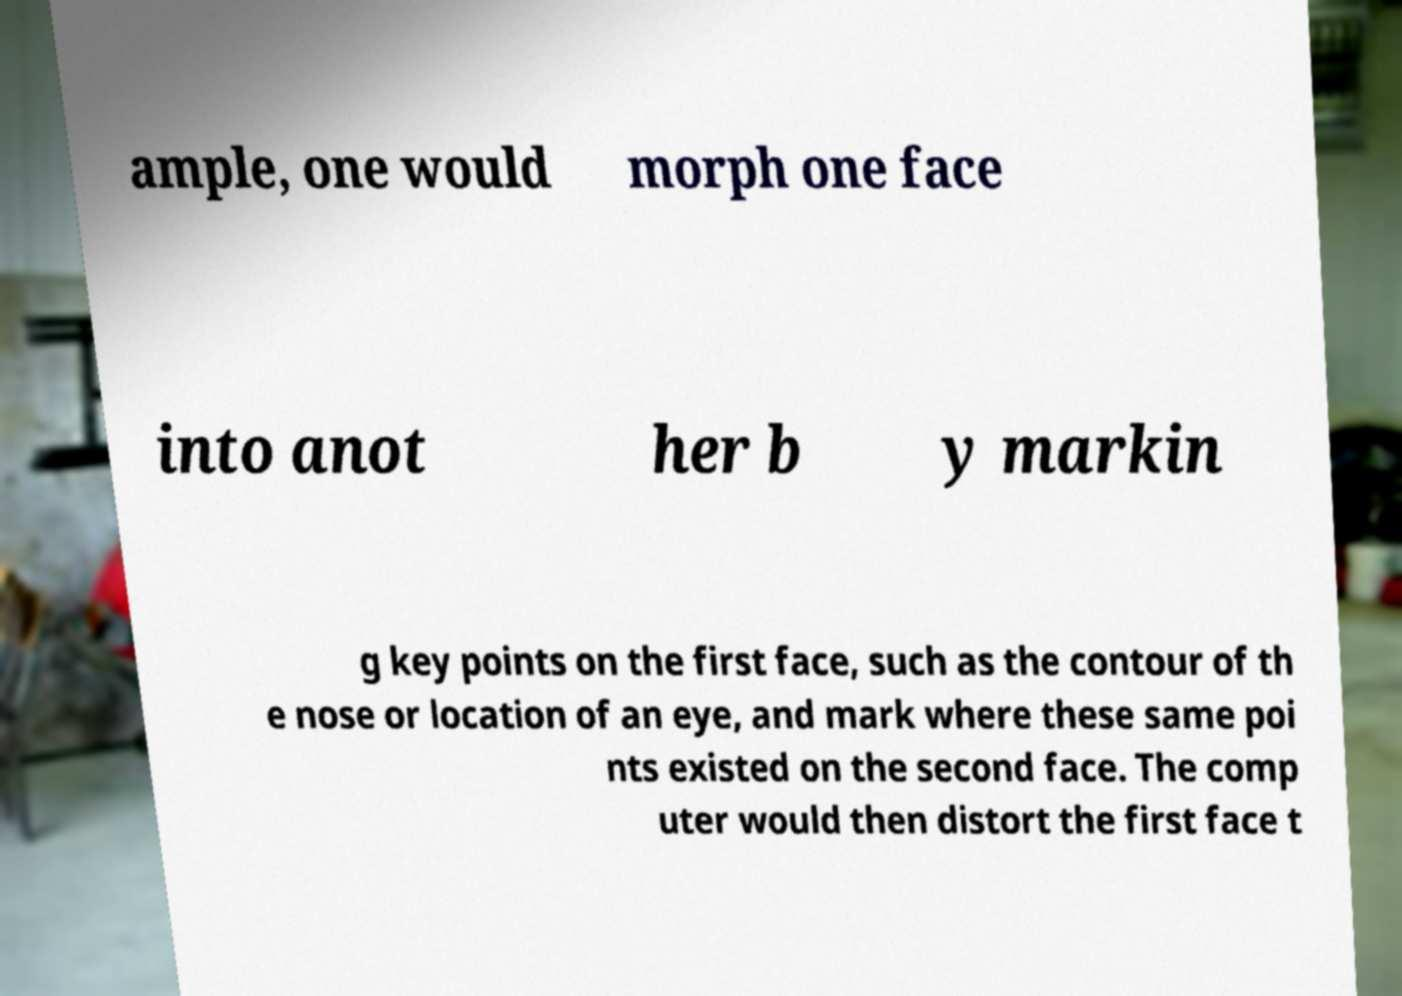There's text embedded in this image that I need extracted. Can you transcribe it verbatim? ample, one would morph one face into anot her b y markin g key points on the first face, such as the contour of th e nose or location of an eye, and mark where these same poi nts existed on the second face. The comp uter would then distort the first face t 